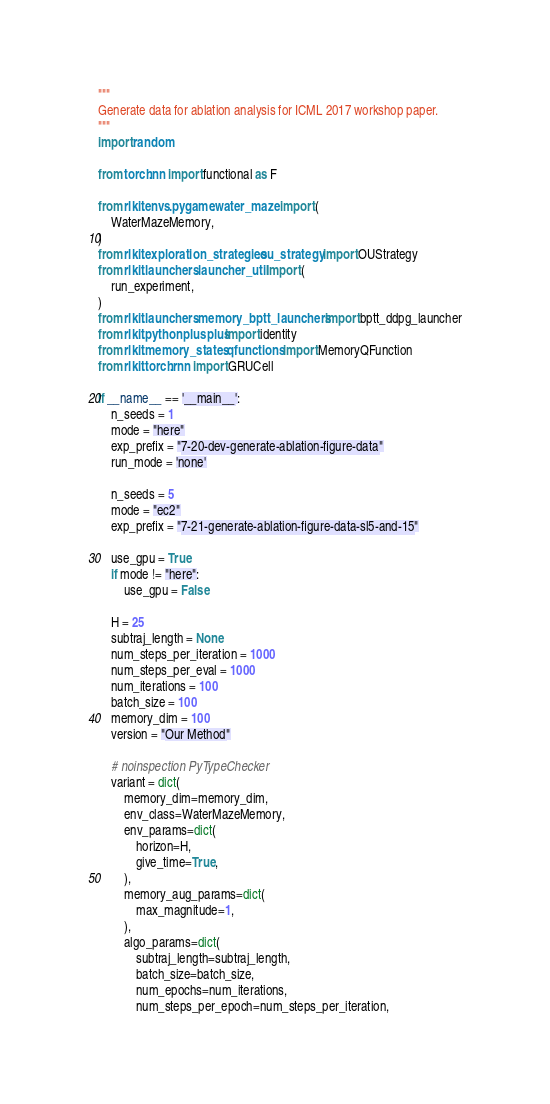<code> <loc_0><loc_0><loc_500><loc_500><_Python_>"""
Generate data for ablation analysis for ICML 2017 workshop paper.
"""
import random

from torch.nn import functional as F

from rlkit.envs.pygame.water_maze import (
    WaterMazeMemory,
)
from rlkit.exploration_strategies.ou_strategy import OUStrategy
from rlkit.launchers.launcher_util import (
    run_experiment,
)
from rlkit.launchers.memory_bptt_launchers import bptt_ddpg_launcher
from rlkit.pythonplusplus import identity
from rlkit.memory_states.qfunctions import MemoryQFunction
from rlkit.torch.rnn import GRUCell

if __name__ == '__main__':
    n_seeds = 1
    mode = "here"
    exp_prefix = "7-20-dev-generate-ablation-figure-data"
    run_mode = 'none'

    n_seeds = 5
    mode = "ec2"
    exp_prefix = "7-21-generate-ablation-figure-data-sl5-and-15"

    use_gpu = True
    if mode != "here":
        use_gpu = False

    H = 25
    subtraj_length = None
    num_steps_per_iteration = 1000
    num_steps_per_eval = 1000
    num_iterations = 100
    batch_size = 100
    memory_dim = 100
    version = "Our Method"

    # noinspection PyTypeChecker
    variant = dict(
        memory_dim=memory_dim,
        env_class=WaterMazeMemory,
        env_params=dict(
            horizon=H,
            give_time=True,
        ),
        memory_aug_params=dict(
            max_magnitude=1,
        ),
        algo_params=dict(
            subtraj_length=subtraj_length,
            batch_size=batch_size,
            num_epochs=num_iterations,
            num_steps_per_epoch=num_steps_per_iteration,</code> 